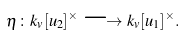<formula> <loc_0><loc_0><loc_500><loc_500>\eta \colon k _ { v } [ u _ { 2 } ] ^ { \times } \longrightarrow k _ { v } [ u _ { 1 } ] ^ { \times } .</formula> 